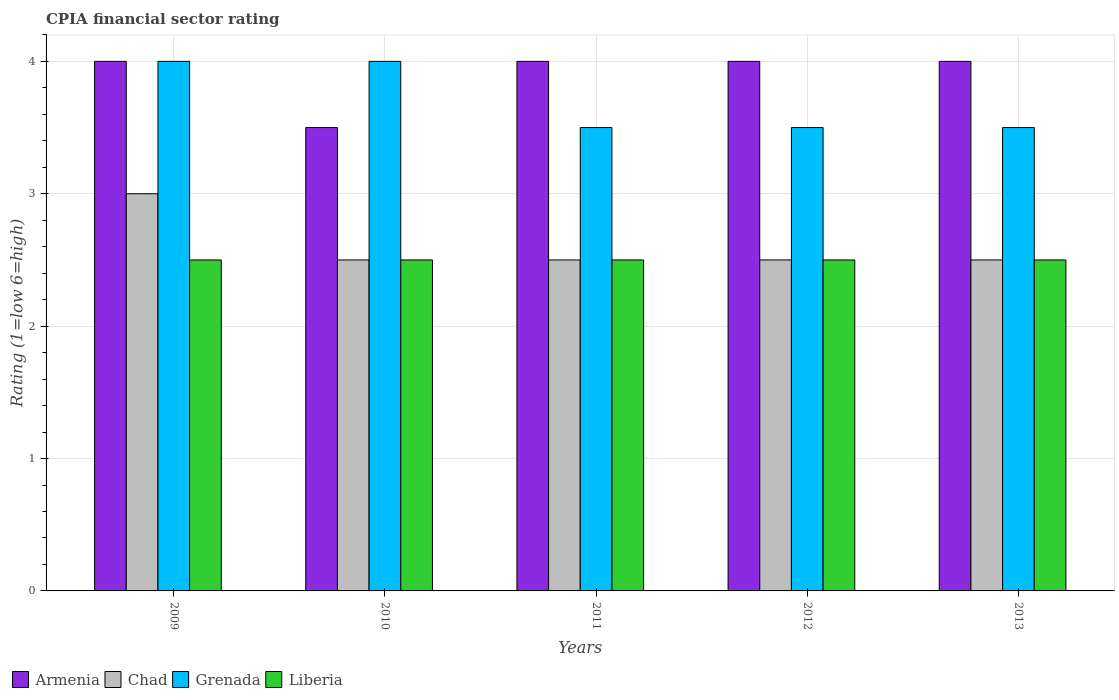How many different coloured bars are there?
Ensure brevity in your answer.  4. How many bars are there on the 1st tick from the left?
Your answer should be very brief. 4. How many bars are there on the 3rd tick from the right?
Your answer should be compact. 4. Across all years, what is the maximum CPIA rating in Grenada?
Your response must be concise. 4. Across all years, what is the minimum CPIA rating in Chad?
Provide a short and direct response. 2.5. In which year was the CPIA rating in Chad maximum?
Provide a short and direct response. 2009. In which year was the CPIA rating in Armenia minimum?
Your answer should be very brief. 2010. What is the difference between the CPIA rating in Chad in 2009 and that in 2010?
Offer a very short reply. 0.5. What is the difference between the CPIA rating in Liberia in 2011 and the CPIA rating in Armenia in 2012?
Your answer should be very brief. -1.5. What is the average CPIA rating in Armenia per year?
Your response must be concise. 3.9. In the year 2010, what is the difference between the CPIA rating in Grenada and CPIA rating in Armenia?
Provide a succinct answer. 0.5. In how many years, is the CPIA rating in Liberia greater than 2.6?
Provide a succinct answer. 0. What is the ratio of the CPIA rating in Grenada in 2009 to that in 2010?
Offer a very short reply. 1. In how many years, is the CPIA rating in Grenada greater than the average CPIA rating in Grenada taken over all years?
Your answer should be very brief. 2. Is the sum of the CPIA rating in Chad in 2012 and 2013 greater than the maximum CPIA rating in Grenada across all years?
Give a very brief answer. Yes. Is it the case that in every year, the sum of the CPIA rating in Armenia and CPIA rating in Liberia is greater than the sum of CPIA rating in Grenada and CPIA rating in Chad?
Make the answer very short. No. What does the 2nd bar from the left in 2013 represents?
Make the answer very short. Chad. What does the 3rd bar from the right in 2012 represents?
Keep it short and to the point. Chad. Is it the case that in every year, the sum of the CPIA rating in Armenia and CPIA rating in Grenada is greater than the CPIA rating in Liberia?
Ensure brevity in your answer.  Yes. Are all the bars in the graph horizontal?
Give a very brief answer. No. How many years are there in the graph?
Your response must be concise. 5. Does the graph contain any zero values?
Provide a short and direct response. No. How many legend labels are there?
Provide a succinct answer. 4. What is the title of the graph?
Give a very brief answer. CPIA financial sector rating. What is the label or title of the X-axis?
Offer a very short reply. Years. What is the label or title of the Y-axis?
Offer a very short reply. Rating (1=low 6=high). What is the Rating (1=low 6=high) of Liberia in 2009?
Give a very brief answer. 2.5. What is the Rating (1=low 6=high) in Armenia in 2010?
Ensure brevity in your answer.  3.5. What is the Rating (1=low 6=high) of Chad in 2010?
Keep it short and to the point. 2.5. What is the Rating (1=low 6=high) in Grenada in 2010?
Provide a short and direct response. 4. What is the Rating (1=low 6=high) in Liberia in 2010?
Provide a succinct answer. 2.5. What is the Rating (1=low 6=high) of Armenia in 2011?
Provide a short and direct response. 4. What is the Rating (1=low 6=high) in Liberia in 2011?
Keep it short and to the point. 2.5. What is the Rating (1=low 6=high) of Chad in 2012?
Offer a terse response. 2.5. What is the Rating (1=low 6=high) of Grenada in 2012?
Your response must be concise. 3.5. What is the Rating (1=low 6=high) in Chad in 2013?
Offer a terse response. 2.5. What is the Rating (1=low 6=high) in Liberia in 2013?
Offer a terse response. 2.5. Across all years, what is the maximum Rating (1=low 6=high) of Armenia?
Your answer should be compact. 4. Across all years, what is the maximum Rating (1=low 6=high) in Chad?
Provide a short and direct response. 3. Across all years, what is the minimum Rating (1=low 6=high) of Armenia?
Your response must be concise. 3.5. Across all years, what is the minimum Rating (1=low 6=high) of Chad?
Give a very brief answer. 2.5. What is the total Rating (1=low 6=high) in Armenia in the graph?
Offer a very short reply. 19.5. What is the total Rating (1=low 6=high) of Grenada in the graph?
Your answer should be compact. 18.5. What is the difference between the Rating (1=low 6=high) of Grenada in 2009 and that in 2010?
Give a very brief answer. 0. What is the difference between the Rating (1=low 6=high) in Armenia in 2009 and that in 2011?
Ensure brevity in your answer.  0. What is the difference between the Rating (1=low 6=high) of Chad in 2009 and that in 2011?
Your answer should be compact. 0.5. What is the difference between the Rating (1=low 6=high) in Grenada in 2009 and that in 2011?
Offer a terse response. 0.5. What is the difference between the Rating (1=low 6=high) of Liberia in 2009 and that in 2011?
Offer a very short reply. 0. What is the difference between the Rating (1=low 6=high) in Armenia in 2009 and that in 2012?
Your answer should be very brief. 0. What is the difference between the Rating (1=low 6=high) of Chad in 2009 and that in 2012?
Your answer should be compact. 0.5. What is the difference between the Rating (1=low 6=high) in Grenada in 2009 and that in 2012?
Provide a short and direct response. 0.5. What is the difference between the Rating (1=low 6=high) of Armenia in 2009 and that in 2013?
Offer a terse response. 0. What is the difference between the Rating (1=low 6=high) of Armenia in 2010 and that in 2011?
Provide a succinct answer. -0.5. What is the difference between the Rating (1=low 6=high) in Liberia in 2010 and that in 2011?
Provide a short and direct response. 0. What is the difference between the Rating (1=low 6=high) of Chad in 2010 and that in 2012?
Your answer should be very brief. 0. What is the difference between the Rating (1=low 6=high) in Grenada in 2010 and that in 2012?
Provide a succinct answer. 0.5. What is the difference between the Rating (1=low 6=high) of Armenia in 2010 and that in 2013?
Ensure brevity in your answer.  -0.5. What is the difference between the Rating (1=low 6=high) of Liberia in 2010 and that in 2013?
Provide a succinct answer. 0. What is the difference between the Rating (1=low 6=high) of Armenia in 2011 and that in 2012?
Give a very brief answer. 0. What is the difference between the Rating (1=low 6=high) in Armenia in 2011 and that in 2013?
Provide a short and direct response. 0. What is the difference between the Rating (1=low 6=high) of Chad in 2011 and that in 2013?
Provide a short and direct response. 0. What is the difference between the Rating (1=low 6=high) in Grenada in 2011 and that in 2013?
Your response must be concise. 0. What is the difference between the Rating (1=low 6=high) of Chad in 2012 and that in 2013?
Provide a succinct answer. 0. What is the difference between the Rating (1=low 6=high) of Grenada in 2012 and that in 2013?
Your answer should be compact. 0. What is the difference between the Rating (1=low 6=high) of Armenia in 2009 and the Rating (1=low 6=high) of Chad in 2010?
Provide a succinct answer. 1.5. What is the difference between the Rating (1=low 6=high) of Chad in 2009 and the Rating (1=low 6=high) of Grenada in 2010?
Your response must be concise. -1. What is the difference between the Rating (1=low 6=high) in Chad in 2009 and the Rating (1=low 6=high) in Liberia in 2010?
Offer a terse response. 0.5. What is the difference between the Rating (1=low 6=high) of Armenia in 2009 and the Rating (1=low 6=high) of Grenada in 2011?
Give a very brief answer. 0.5. What is the difference between the Rating (1=low 6=high) of Armenia in 2009 and the Rating (1=low 6=high) of Liberia in 2011?
Make the answer very short. 1.5. What is the difference between the Rating (1=low 6=high) in Grenada in 2009 and the Rating (1=low 6=high) in Liberia in 2011?
Your answer should be very brief. 1.5. What is the difference between the Rating (1=low 6=high) in Armenia in 2009 and the Rating (1=low 6=high) in Chad in 2012?
Provide a succinct answer. 1.5. What is the difference between the Rating (1=low 6=high) in Armenia in 2009 and the Rating (1=low 6=high) in Liberia in 2012?
Your answer should be very brief. 1.5. What is the difference between the Rating (1=low 6=high) of Chad in 2009 and the Rating (1=low 6=high) of Liberia in 2012?
Keep it short and to the point. 0.5. What is the difference between the Rating (1=low 6=high) of Armenia in 2009 and the Rating (1=low 6=high) of Chad in 2013?
Ensure brevity in your answer.  1.5. What is the difference between the Rating (1=low 6=high) of Armenia in 2009 and the Rating (1=low 6=high) of Grenada in 2013?
Provide a succinct answer. 0.5. What is the difference between the Rating (1=low 6=high) in Chad in 2009 and the Rating (1=low 6=high) in Liberia in 2013?
Your response must be concise. 0.5. What is the difference between the Rating (1=low 6=high) of Grenada in 2009 and the Rating (1=low 6=high) of Liberia in 2013?
Ensure brevity in your answer.  1.5. What is the difference between the Rating (1=low 6=high) in Armenia in 2010 and the Rating (1=low 6=high) in Chad in 2011?
Give a very brief answer. 1. What is the difference between the Rating (1=low 6=high) in Armenia in 2010 and the Rating (1=low 6=high) in Liberia in 2011?
Keep it short and to the point. 1. What is the difference between the Rating (1=low 6=high) of Chad in 2010 and the Rating (1=low 6=high) of Liberia in 2011?
Provide a succinct answer. 0. What is the difference between the Rating (1=low 6=high) of Armenia in 2010 and the Rating (1=low 6=high) of Chad in 2012?
Ensure brevity in your answer.  1. What is the difference between the Rating (1=low 6=high) in Armenia in 2010 and the Rating (1=low 6=high) in Grenada in 2012?
Your response must be concise. 0. What is the difference between the Rating (1=low 6=high) of Grenada in 2010 and the Rating (1=low 6=high) of Liberia in 2012?
Make the answer very short. 1.5. What is the difference between the Rating (1=low 6=high) in Armenia in 2010 and the Rating (1=low 6=high) in Grenada in 2013?
Provide a short and direct response. 0. What is the difference between the Rating (1=low 6=high) of Armenia in 2010 and the Rating (1=low 6=high) of Liberia in 2013?
Your answer should be compact. 1. What is the difference between the Rating (1=low 6=high) of Chad in 2010 and the Rating (1=low 6=high) of Grenada in 2013?
Give a very brief answer. -1. What is the difference between the Rating (1=low 6=high) in Chad in 2010 and the Rating (1=low 6=high) in Liberia in 2013?
Your answer should be very brief. 0. What is the difference between the Rating (1=low 6=high) of Grenada in 2010 and the Rating (1=low 6=high) of Liberia in 2013?
Ensure brevity in your answer.  1.5. What is the difference between the Rating (1=low 6=high) in Armenia in 2011 and the Rating (1=low 6=high) in Grenada in 2012?
Keep it short and to the point. 0.5. What is the difference between the Rating (1=low 6=high) in Chad in 2011 and the Rating (1=low 6=high) in Liberia in 2012?
Ensure brevity in your answer.  0. What is the difference between the Rating (1=low 6=high) in Armenia in 2011 and the Rating (1=low 6=high) in Chad in 2013?
Give a very brief answer. 1.5. What is the difference between the Rating (1=low 6=high) in Armenia in 2011 and the Rating (1=low 6=high) in Grenada in 2013?
Keep it short and to the point. 0.5. What is the difference between the Rating (1=low 6=high) in Chad in 2011 and the Rating (1=low 6=high) in Grenada in 2013?
Your response must be concise. -1. What is the difference between the Rating (1=low 6=high) of Armenia in 2012 and the Rating (1=low 6=high) of Liberia in 2013?
Provide a short and direct response. 1.5. What is the difference between the Rating (1=low 6=high) in Chad in 2012 and the Rating (1=low 6=high) in Grenada in 2013?
Your response must be concise. -1. What is the difference between the Rating (1=low 6=high) in Chad in 2012 and the Rating (1=low 6=high) in Liberia in 2013?
Your response must be concise. 0. What is the difference between the Rating (1=low 6=high) in Grenada in 2012 and the Rating (1=low 6=high) in Liberia in 2013?
Make the answer very short. 1. What is the average Rating (1=low 6=high) in Armenia per year?
Offer a very short reply. 3.9. What is the average Rating (1=low 6=high) in Liberia per year?
Your answer should be very brief. 2.5. In the year 2009, what is the difference between the Rating (1=low 6=high) in Armenia and Rating (1=low 6=high) in Chad?
Your answer should be very brief. 1. In the year 2009, what is the difference between the Rating (1=low 6=high) of Armenia and Rating (1=low 6=high) of Liberia?
Give a very brief answer. 1.5. In the year 2010, what is the difference between the Rating (1=low 6=high) in Armenia and Rating (1=low 6=high) in Chad?
Make the answer very short. 1. In the year 2010, what is the difference between the Rating (1=low 6=high) of Armenia and Rating (1=low 6=high) of Grenada?
Your answer should be very brief. -0.5. In the year 2010, what is the difference between the Rating (1=low 6=high) of Chad and Rating (1=low 6=high) of Grenada?
Make the answer very short. -1.5. In the year 2010, what is the difference between the Rating (1=low 6=high) in Chad and Rating (1=low 6=high) in Liberia?
Provide a succinct answer. 0. In the year 2011, what is the difference between the Rating (1=low 6=high) of Armenia and Rating (1=low 6=high) of Chad?
Provide a succinct answer. 1.5. In the year 2011, what is the difference between the Rating (1=low 6=high) in Armenia and Rating (1=low 6=high) in Liberia?
Make the answer very short. 1.5. In the year 2011, what is the difference between the Rating (1=low 6=high) of Chad and Rating (1=low 6=high) of Grenada?
Provide a short and direct response. -1. In the year 2011, what is the difference between the Rating (1=low 6=high) in Chad and Rating (1=low 6=high) in Liberia?
Your answer should be very brief. 0. In the year 2012, what is the difference between the Rating (1=low 6=high) in Chad and Rating (1=low 6=high) in Grenada?
Your response must be concise. -1. In the year 2012, what is the difference between the Rating (1=low 6=high) of Chad and Rating (1=low 6=high) of Liberia?
Give a very brief answer. 0. In the year 2012, what is the difference between the Rating (1=low 6=high) in Grenada and Rating (1=low 6=high) in Liberia?
Give a very brief answer. 1. In the year 2013, what is the difference between the Rating (1=low 6=high) of Armenia and Rating (1=low 6=high) of Chad?
Your response must be concise. 1.5. In the year 2013, what is the difference between the Rating (1=low 6=high) of Armenia and Rating (1=low 6=high) of Grenada?
Provide a short and direct response. 0.5. In the year 2013, what is the difference between the Rating (1=low 6=high) of Grenada and Rating (1=low 6=high) of Liberia?
Keep it short and to the point. 1. What is the ratio of the Rating (1=low 6=high) of Armenia in 2009 to that in 2010?
Make the answer very short. 1.14. What is the ratio of the Rating (1=low 6=high) of Chad in 2009 to that in 2010?
Your answer should be very brief. 1.2. What is the ratio of the Rating (1=low 6=high) of Armenia in 2009 to that in 2011?
Provide a succinct answer. 1. What is the ratio of the Rating (1=low 6=high) of Liberia in 2009 to that in 2011?
Give a very brief answer. 1. What is the ratio of the Rating (1=low 6=high) of Armenia in 2009 to that in 2012?
Provide a short and direct response. 1. What is the ratio of the Rating (1=low 6=high) of Liberia in 2009 to that in 2012?
Make the answer very short. 1. What is the ratio of the Rating (1=low 6=high) in Liberia in 2009 to that in 2013?
Ensure brevity in your answer.  1. What is the ratio of the Rating (1=low 6=high) of Chad in 2010 to that in 2011?
Provide a succinct answer. 1. What is the ratio of the Rating (1=low 6=high) of Grenada in 2010 to that in 2011?
Provide a short and direct response. 1.14. What is the ratio of the Rating (1=low 6=high) in Liberia in 2010 to that in 2011?
Make the answer very short. 1. What is the ratio of the Rating (1=low 6=high) in Chad in 2010 to that in 2012?
Your answer should be very brief. 1. What is the ratio of the Rating (1=low 6=high) of Grenada in 2010 to that in 2012?
Provide a short and direct response. 1.14. What is the ratio of the Rating (1=low 6=high) of Liberia in 2010 to that in 2012?
Your response must be concise. 1. What is the ratio of the Rating (1=low 6=high) of Chad in 2011 to that in 2012?
Your answer should be very brief. 1. What is the ratio of the Rating (1=low 6=high) in Chad in 2011 to that in 2013?
Offer a terse response. 1. What is the ratio of the Rating (1=low 6=high) in Grenada in 2011 to that in 2013?
Make the answer very short. 1. What is the ratio of the Rating (1=low 6=high) of Grenada in 2012 to that in 2013?
Offer a very short reply. 1. What is the difference between the highest and the second highest Rating (1=low 6=high) in Armenia?
Give a very brief answer. 0. What is the difference between the highest and the second highest Rating (1=low 6=high) in Grenada?
Give a very brief answer. 0. What is the difference between the highest and the second highest Rating (1=low 6=high) in Liberia?
Your response must be concise. 0. What is the difference between the highest and the lowest Rating (1=low 6=high) of Armenia?
Keep it short and to the point. 0.5. 